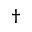<formula> <loc_0><loc_0><loc_500><loc_500>^ { \dag }</formula> 